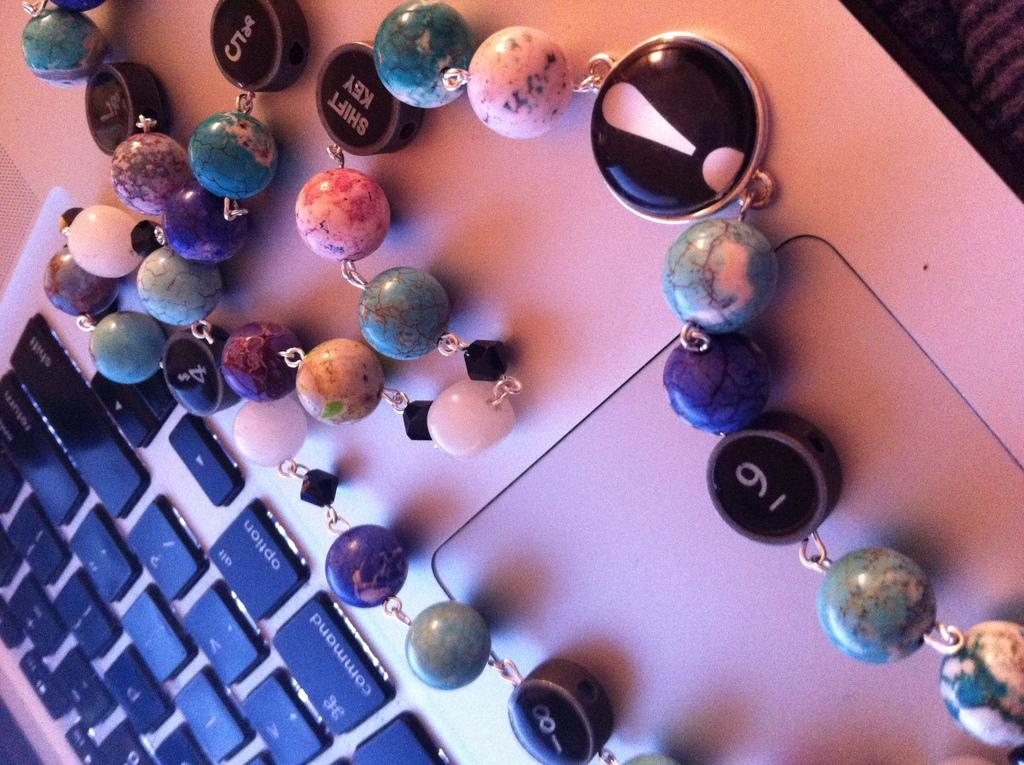What is placed on top of the laptop in the image? There is an ornament on the laptop. What can be seen on the ornament? There is text and numbers on the ornament. What is written on the keys of the laptop? There is text on the keys of the laptop. What symbols are present on the keys of the laptop? There are symbols on the keys of the laptop. What type of religion is being practiced in the image? There is no indication of any religious practice in the image; it features an ornament on a laptop with text and numbers, as well as text and symbols on the laptop keys. 